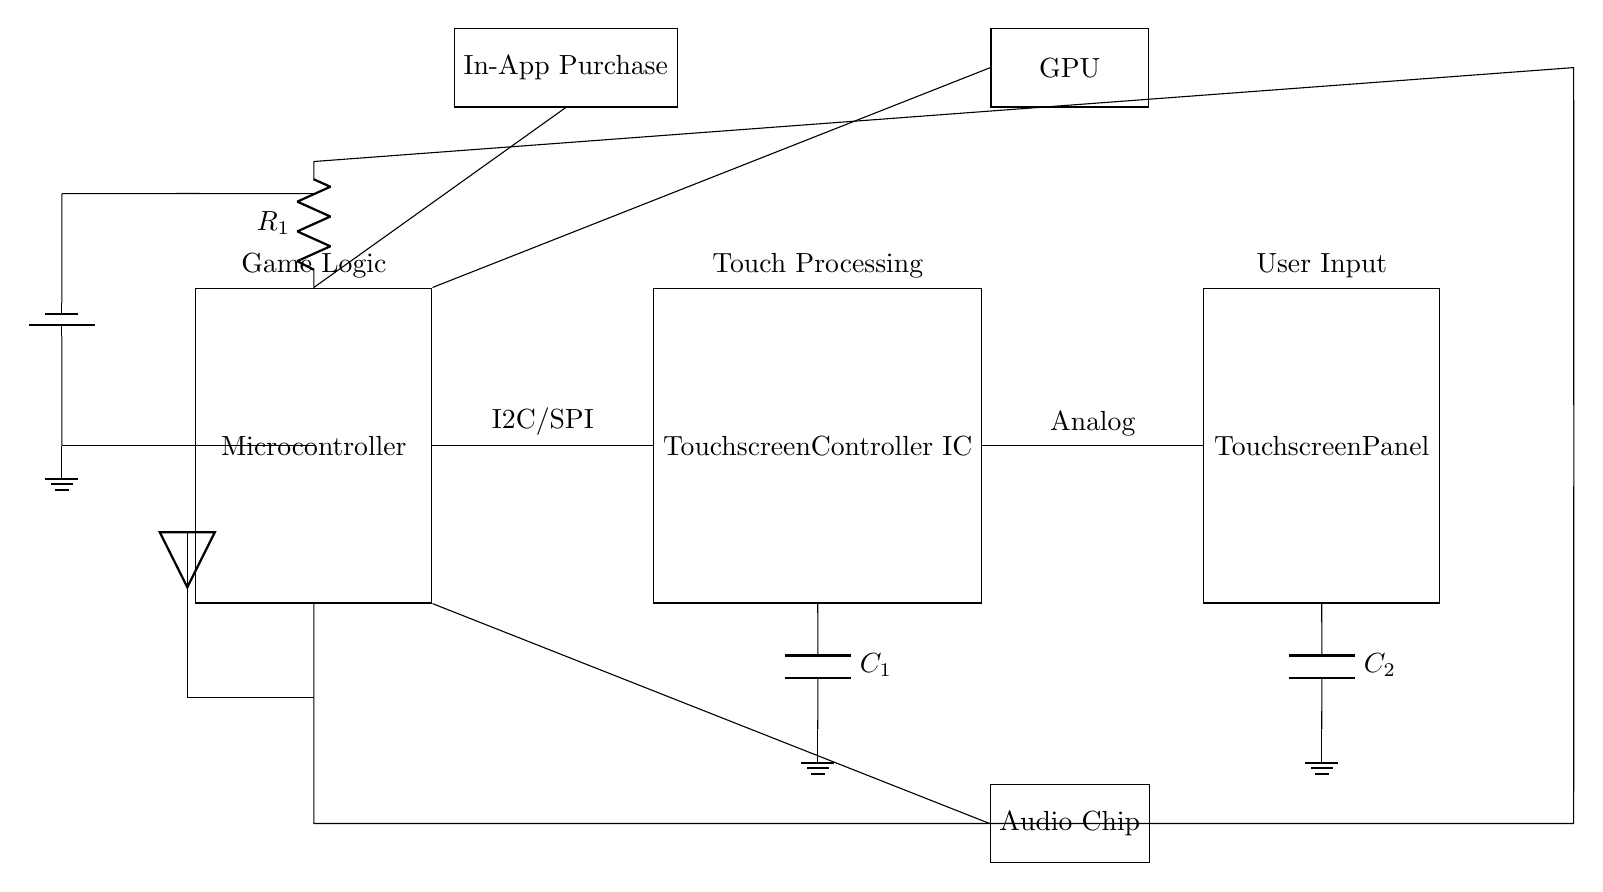What is the main function of the microcontroller? The microcontroller serves as the primary control unit that executes the game logic, processes inputs from the touchscreen controller, and manages communications with other components in the circuit.
Answer: Game Logic What type of connection is used between the microcontroller and the touchscreen controller? The circuit diagram shows that the connection is labeled as I2C/SPI, indicating the communication protocol used to transmit data between these two components.
Answer: I2C/SPI What are the two major components that connect to the touchscreen controller? The two major components connected to the touchscreen controller are the microcontroller on one side and the touchscreen panel on the other side. This connection facilitates input processing from the touch interface to the main control unit.
Answer: Microcontroller and Touchscreen Panel How many capacitors are present in the circuit? The circuit features two capacitors, labeled as C1 and C2, each connected to different components in the design, aiding in filtering and stabilizing voltage levels for the respective ICs.
Answer: Two What does the rectangle labeled "In-App Purchase" signify? The rectangle labeled "In-App Purchase" represents a monetization feature integrated into the game, indicating that the microcontroller manages and processes transactions for in-game purchases, thereby enhancing revenue generation.
Answer: Monetization Feature What role does the GPU play in the circuit? The GPU is connected to the microcontroller, suggesting it is responsible for rendering graphics and images in the game interface, indicating its crucial role in delivering visual performance.
Answer: Graphics Rendering Which component handles audio processing in the circuit? The audio chip handles audio processing in the circuit, indicated by its direct connection to the microcontroller, which manages the overall game logic and audio output.
Answer: Audio Chip 